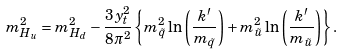Convert formula to latex. <formula><loc_0><loc_0><loc_500><loc_500>m _ { H _ { u } } ^ { 2 } = m _ { H _ { d } } ^ { 2 } - \frac { 3 y _ { t } ^ { 2 } } { 8 \pi ^ { 2 } } \left \{ m _ { \tilde { q } } ^ { 2 } \ln \left ( \frac { k ^ { \prime } } { m _ { \tilde { q } } } \right ) + m _ { \tilde { u } } ^ { 2 } \ln \left ( \frac { k ^ { \prime } } { m _ { \tilde { u } } } \right ) \right \} .</formula> 